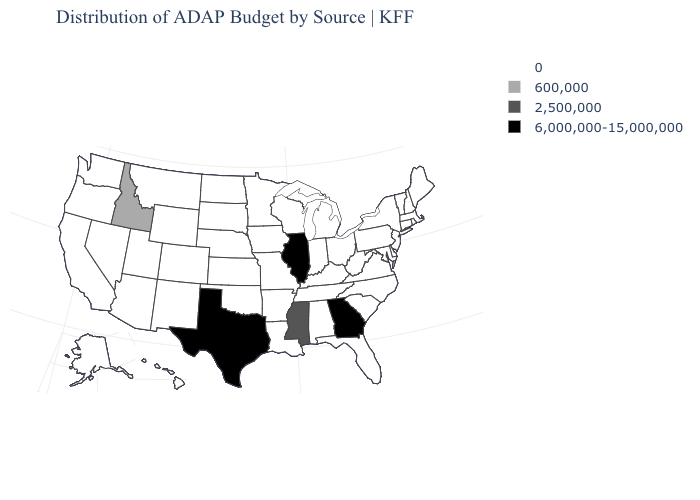What is the value of Nevada?
Short answer required. 0. What is the value of New York?
Keep it brief. 0. Which states have the lowest value in the USA?
Short answer required. Alabama, Alaska, Arizona, Arkansas, California, Colorado, Connecticut, Delaware, Florida, Hawaii, Indiana, Iowa, Kansas, Kentucky, Louisiana, Maine, Maryland, Massachusetts, Michigan, Minnesota, Missouri, Montana, Nebraska, Nevada, New Hampshire, New Jersey, New Mexico, New York, North Carolina, North Dakota, Ohio, Oklahoma, Oregon, Pennsylvania, Rhode Island, South Carolina, South Dakota, Tennessee, Utah, Vermont, Virginia, Washington, West Virginia, Wisconsin, Wyoming. What is the highest value in the USA?
Quick response, please. 6,000,000-15,000,000. Among the states that border Idaho , which have the lowest value?
Give a very brief answer. Montana, Nevada, Oregon, Utah, Washington, Wyoming. Name the states that have a value in the range 2,500,000?
Concise answer only. Mississippi. Among the states that border Colorado , which have the highest value?
Write a very short answer. Arizona, Kansas, Nebraska, New Mexico, Oklahoma, Utah, Wyoming. What is the value of Colorado?
Concise answer only. 0. What is the value of Washington?
Answer briefly. 0. What is the value of Iowa?
Quick response, please. 0. Name the states that have a value in the range 6,000,000-15,000,000?
Keep it brief. Georgia, Illinois, Texas. What is the value of Kentucky?
Answer briefly. 0. What is the lowest value in states that border Nevada?
Quick response, please. 0. Does Iowa have the lowest value in the MidWest?
Be succinct. Yes. Name the states that have a value in the range 2,500,000?
Short answer required. Mississippi. 